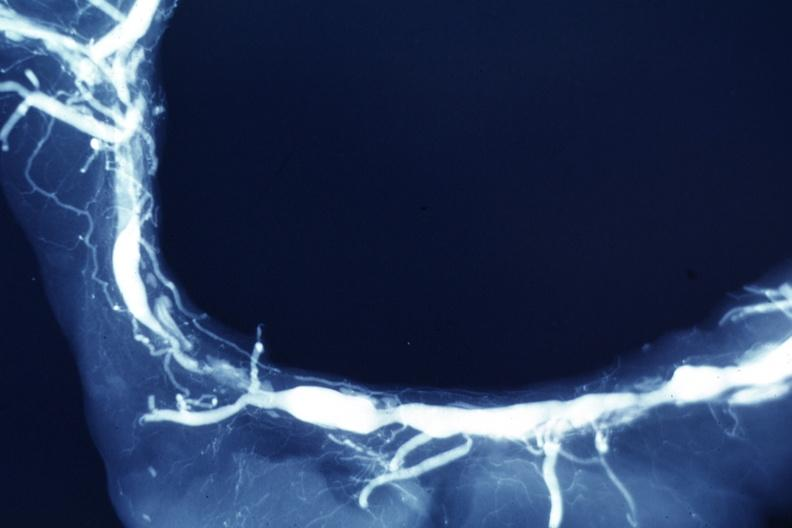s cachexia present?
Answer the question using a single word or phrase. No 